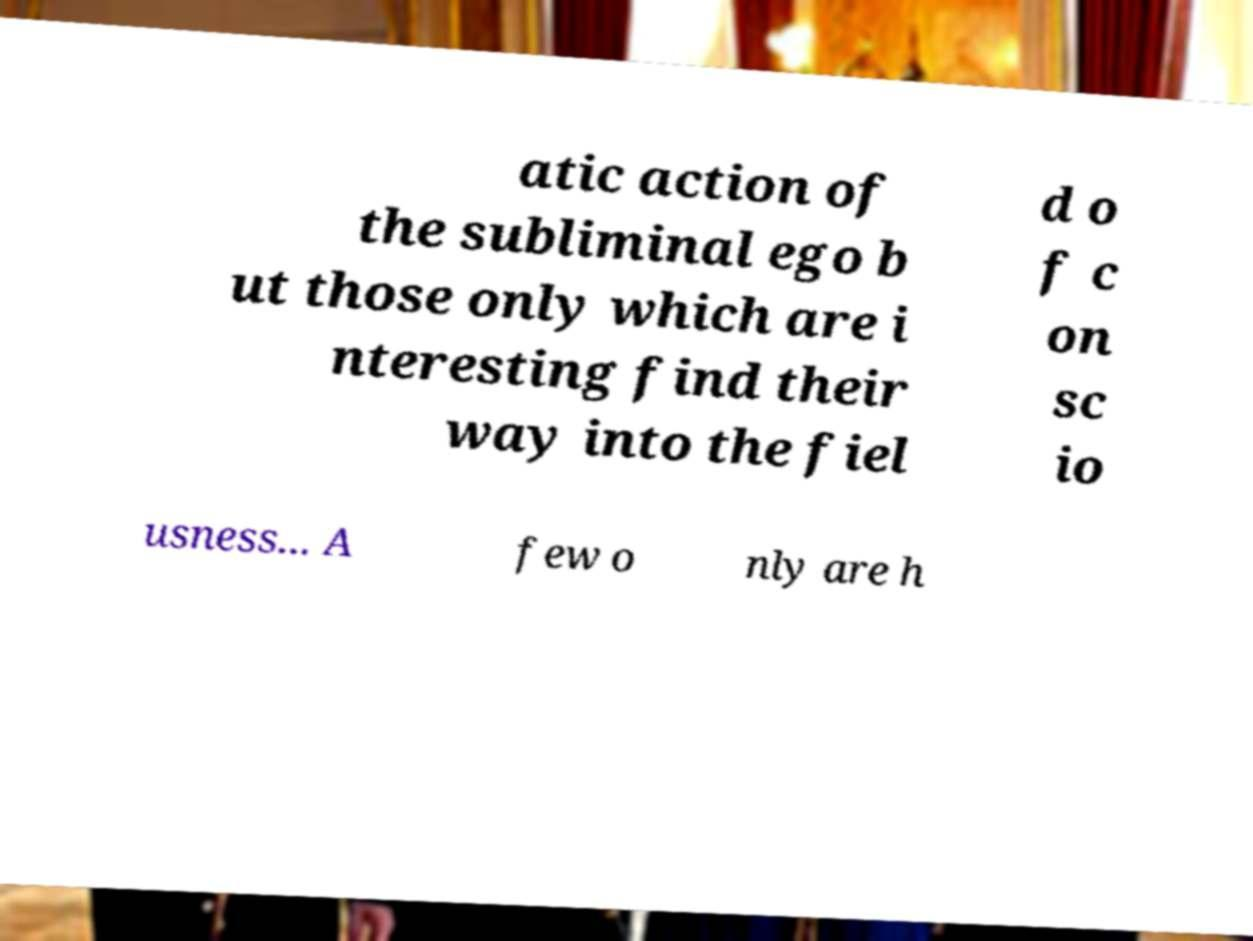Could you extract and type out the text from this image? atic action of the subliminal ego b ut those only which are i nteresting find their way into the fiel d o f c on sc io usness... A few o nly are h 